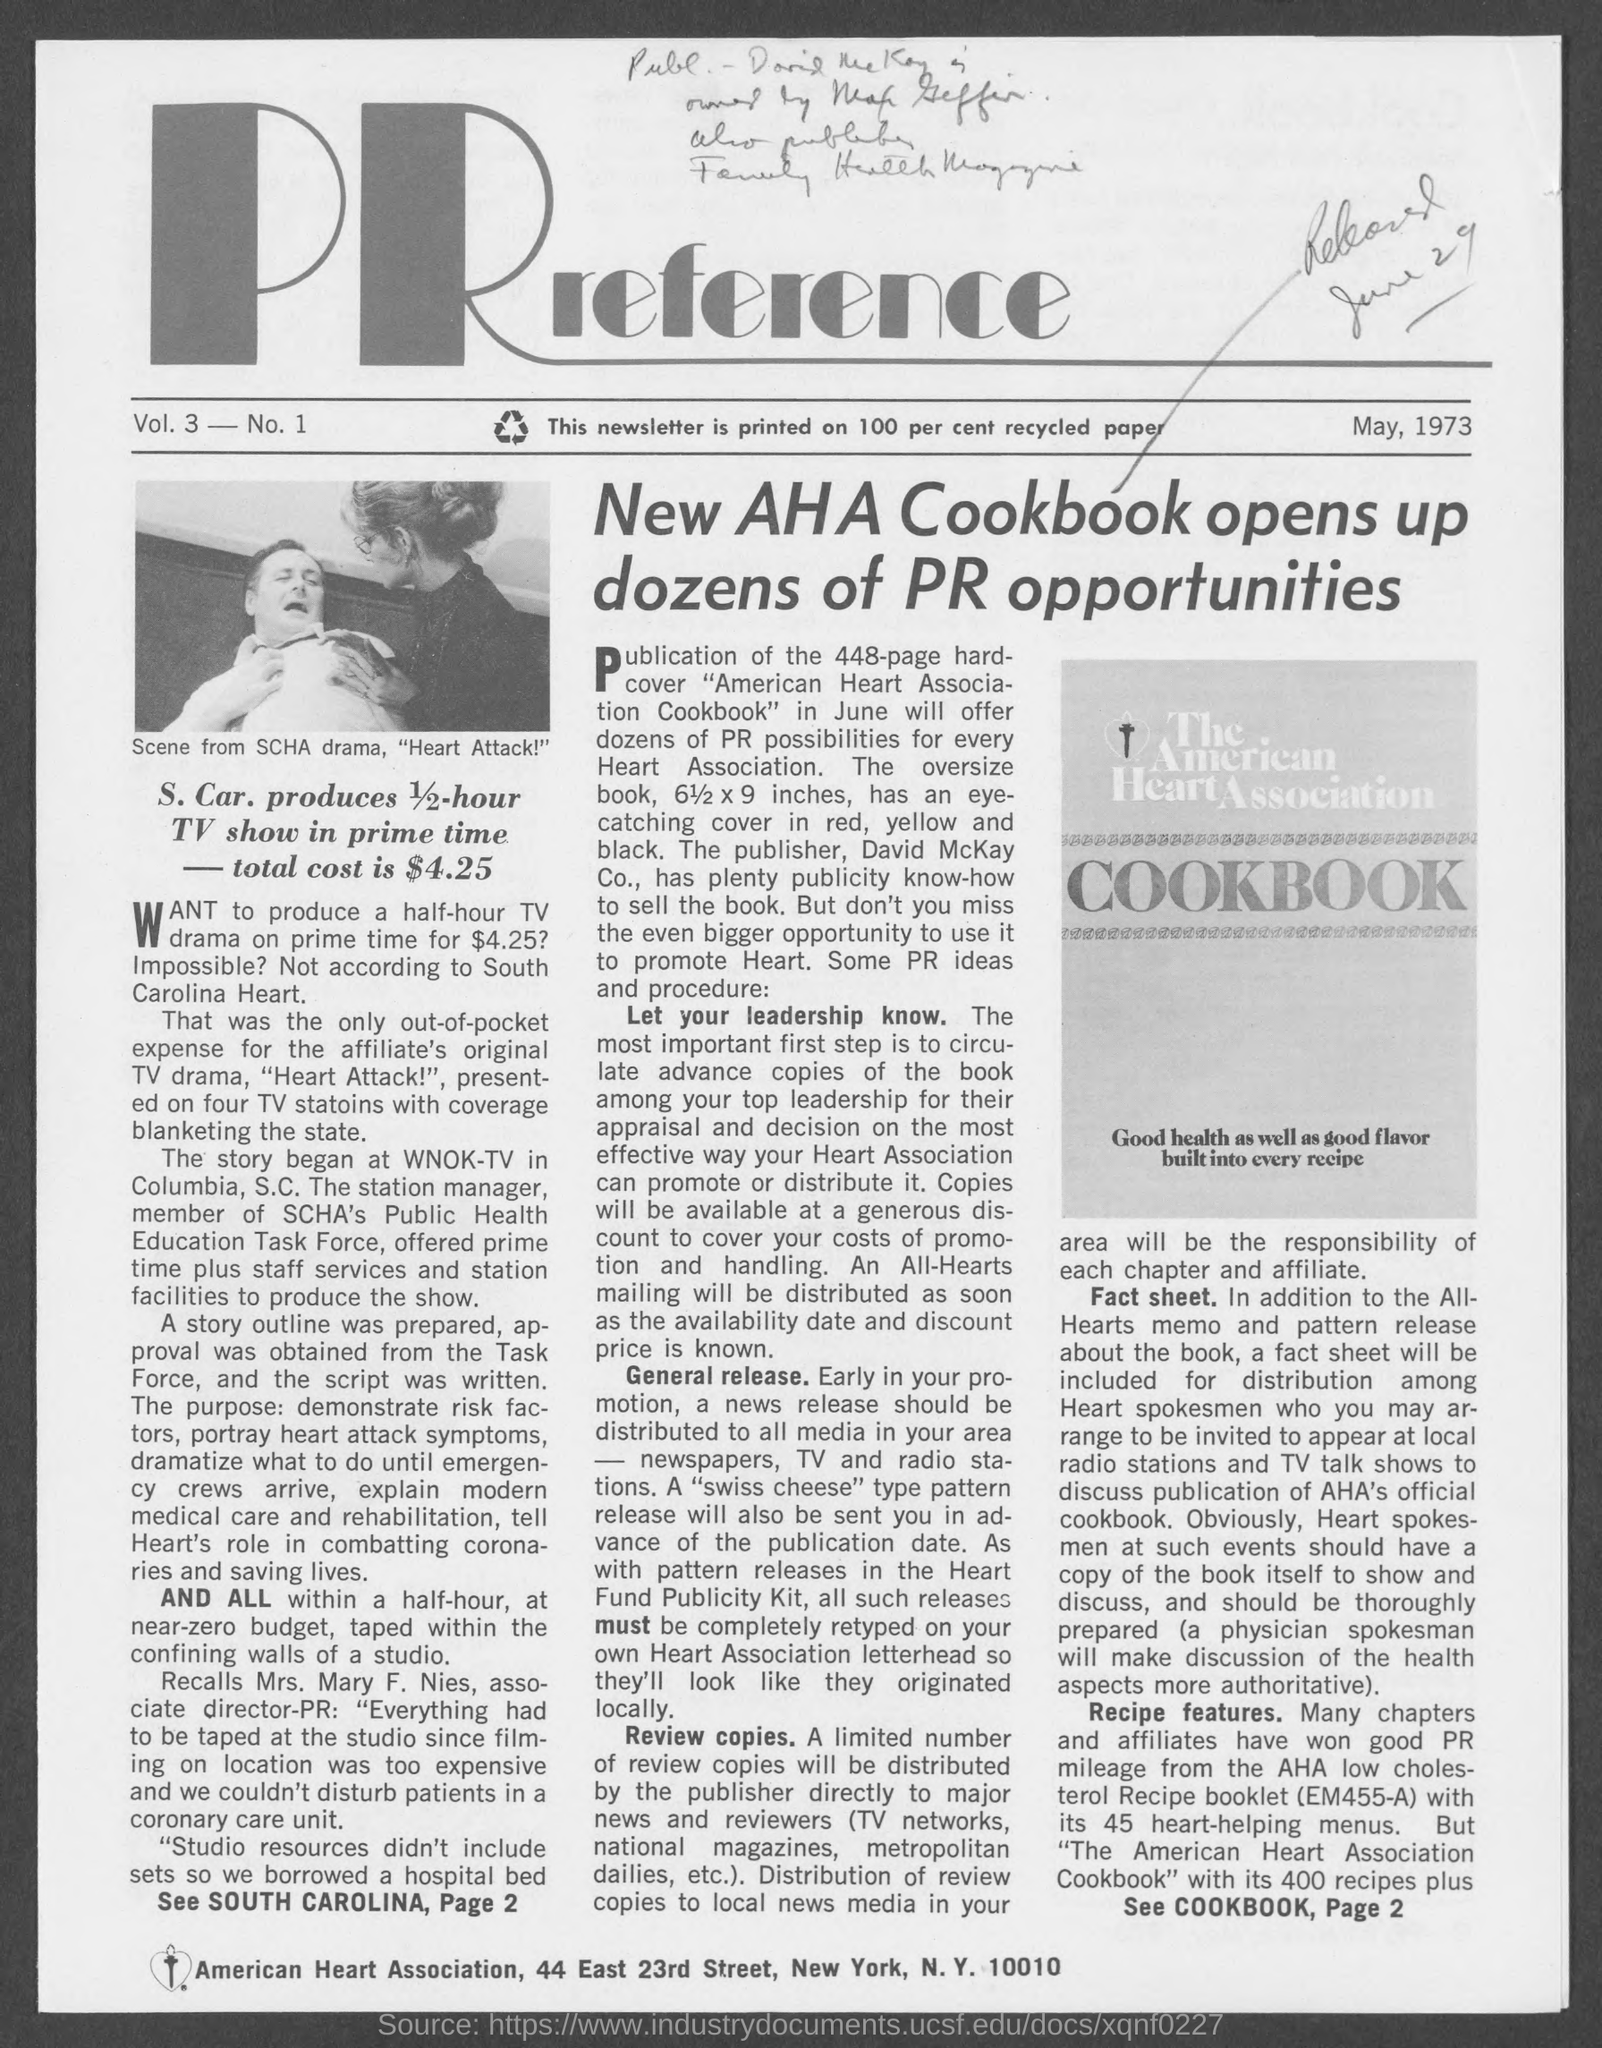Specify some key components in this picture. The date mentioned in the given page is May, 1973. The cost mentioned on the given page is $4.25. 